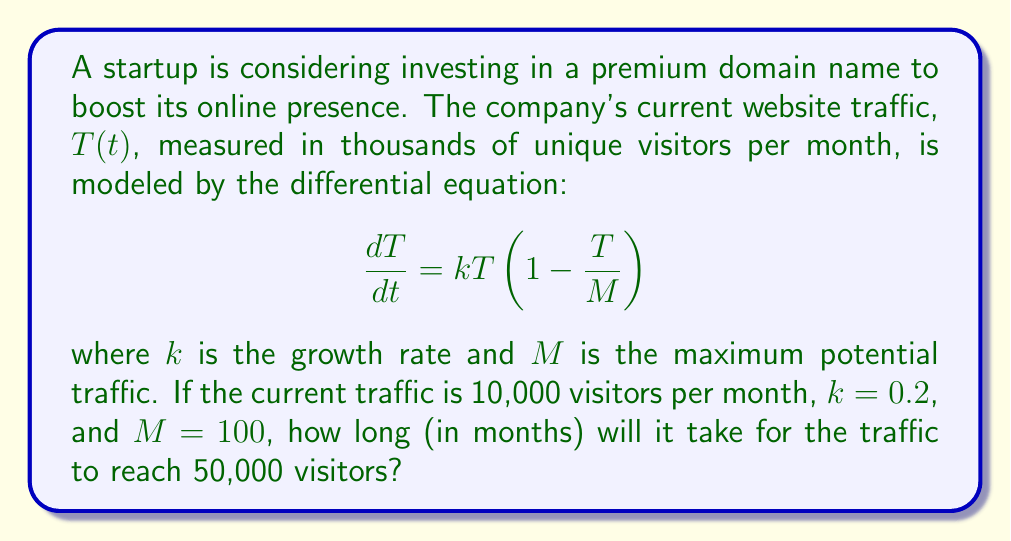Could you help me with this problem? To solve this problem, we'll use the logistic growth model and its solution:

1. The given differential equation is the logistic growth model:
   $$\frac{dT}{dt} = kT(1-\frac{T}{M})$$

2. The solution to this equation is:
   $$T(t) = \frac{M}{1 + (\frac{M}{T_0} - 1)e^{-kt}}$$
   where $T_0$ is the initial traffic.

3. We're given:
   $T_0 = 10$ (thousand visitors)
   $k = 0.2$
   $M = 100$ (thousand visitors)

4. We want to find $t$ when $T(t) = 50$ (thousand visitors)

5. Substituting these values into the equation:
   $$50 = \frac{100}{1 + (\frac{100}{10} - 1)e^{-0.2t}}$$

6. Simplifying:
   $$50 = \frac{100}{1 + 9e^{-0.2t}}$$

7. Solving for $t$:
   $$1 + 9e^{-0.2t} = 2$$
   $$9e^{-0.2t} = 1$$
   $$e^{-0.2t} = \frac{1}{9}$$
   $$-0.2t = \ln(\frac{1}{9})$$
   $$t = -\frac{\ln(\frac{1}{9})}{0.2}$$

8. Calculating the final result:
   $$t = -\frac{\ln(\frac{1}{9})}{0.2} \approx 11.0229$$

Therefore, it will take approximately 11.02 months for the traffic to reach 50,000 visitors.
Answer: 11.02 months 